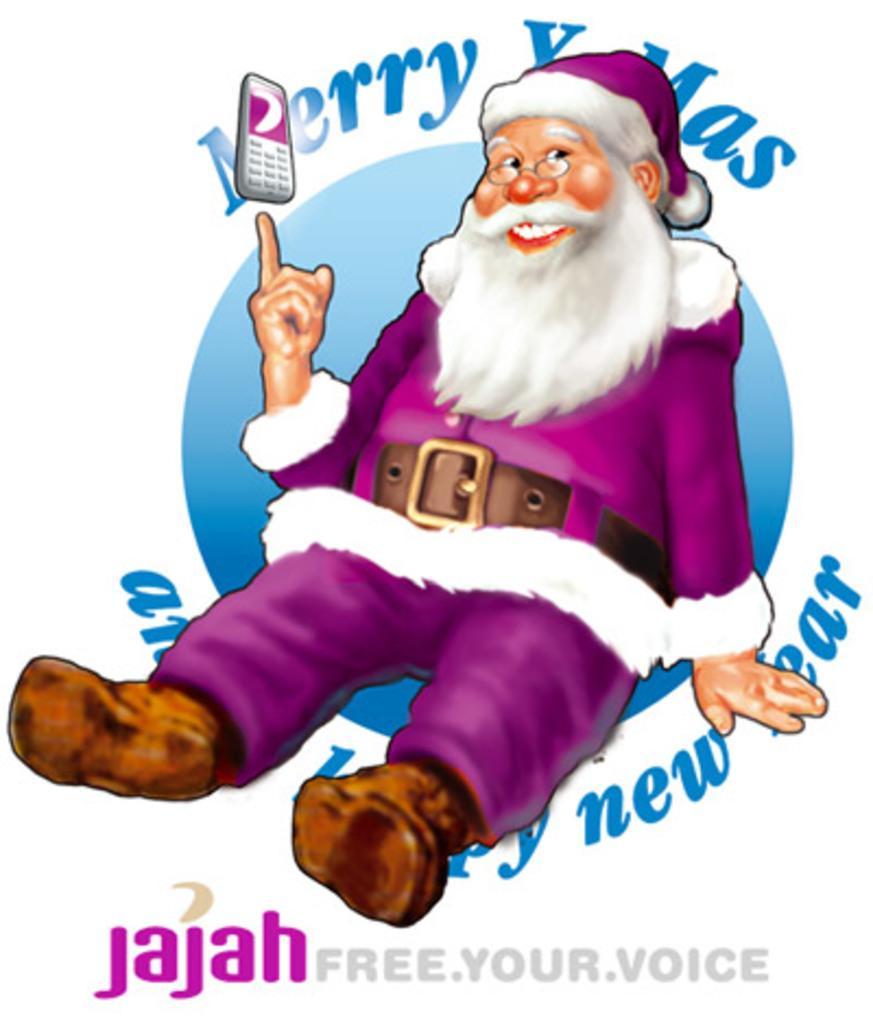Please provide a concise description of this image. There is a cartoon picture of a Santa in the middle of this image, and there is some text at the bottom of this image and at the top of this image as well. 